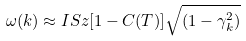Convert formula to latex. <formula><loc_0><loc_0><loc_500><loc_500>\omega ( k ) \approx I S z [ 1 - C ( T ) ] \sqrt { ( 1 - \gamma _ { k } ^ { 2 } ) }</formula> 